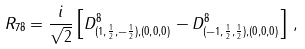Convert formula to latex. <formula><loc_0><loc_0><loc_500><loc_500>R _ { 7 8 } = \frac { i } { \sqrt { 2 } } \left [ D ^ { 8 } _ { ( 1 , \frac { 1 } { 2 } , - \frac { 1 } { 2 } ) , ( 0 , 0 , 0 ) } - D ^ { 8 } _ { ( - 1 , \frac { 1 } { 2 } , \frac { 1 } { 2 } ) , ( 0 , 0 , 0 ) } \right ] \, ,</formula> 